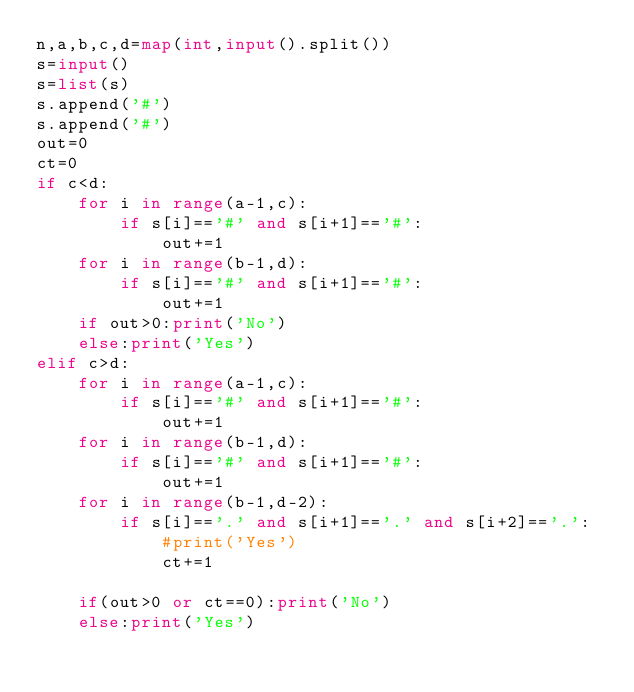<code> <loc_0><loc_0><loc_500><loc_500><_Python_>n,a,b,c,d=map(int,input().split())
s=input()
s=list(s)
s.append('#')
s.append('#')
out=0
ct=0
if c<d:
    for i in range(a-1,c):
        if s[i]=='#' and s[i+1]=='#':
            out+=1
    for i in range(b-1,d):
        if s[i]=='#' and s[i+1]=='#':
            out+=1
    if out>0:print('No')
    else:print('Yes')
elif c>d:
    for i in range(a-1,c):
        if s[i]=='#' and s[i+1]=='#':
            out+=1
    for i in range(b-1,d):
        if s[i]=='#' and s[i+1]=='#':
            out+=1
    for i in range(b-1,d-2):
        if s[i]=='.' and s[i+1]=='.' and s[i+2]=='.':
            #print('Yes')
            ct+=1
        
    if(out>0 or ct==0):print('No')
    else:print('Yes')
 </code> 